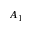Convert formula to latex. <formula><loc_0><loc_0><loc_500><loc_500>A _ { 1 }</formula> 